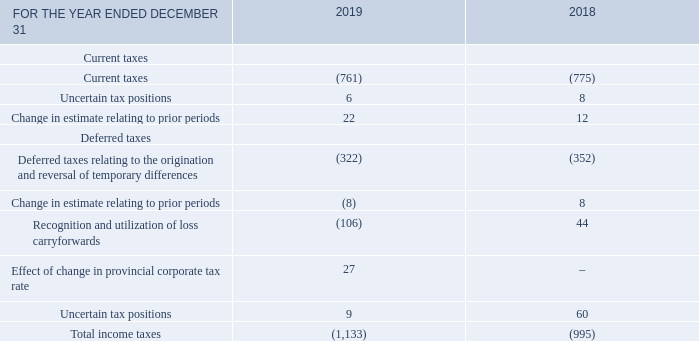Note 8 Income taxes
The following table shows the significant components of income taxes deducted from net earnings.
What does the table show? The significant components of income taxes deducted from net earnings. What is the amount for change in estimate relating to prior periods for current taxes in 2019? 22. What is the amount for uncertain tax positions for current taxes in 2019? 6. How many components of current taxes are there? Current taxes##uncertain tax positions##change in estimate relating to prior periods
Answer: 3. What is the total amount of uncertain tax positions for 2019? 6+9
Answer: 15. What is the change in the change in estimate relating to prior periods for current taxes? 22-12
Answer: 10. 